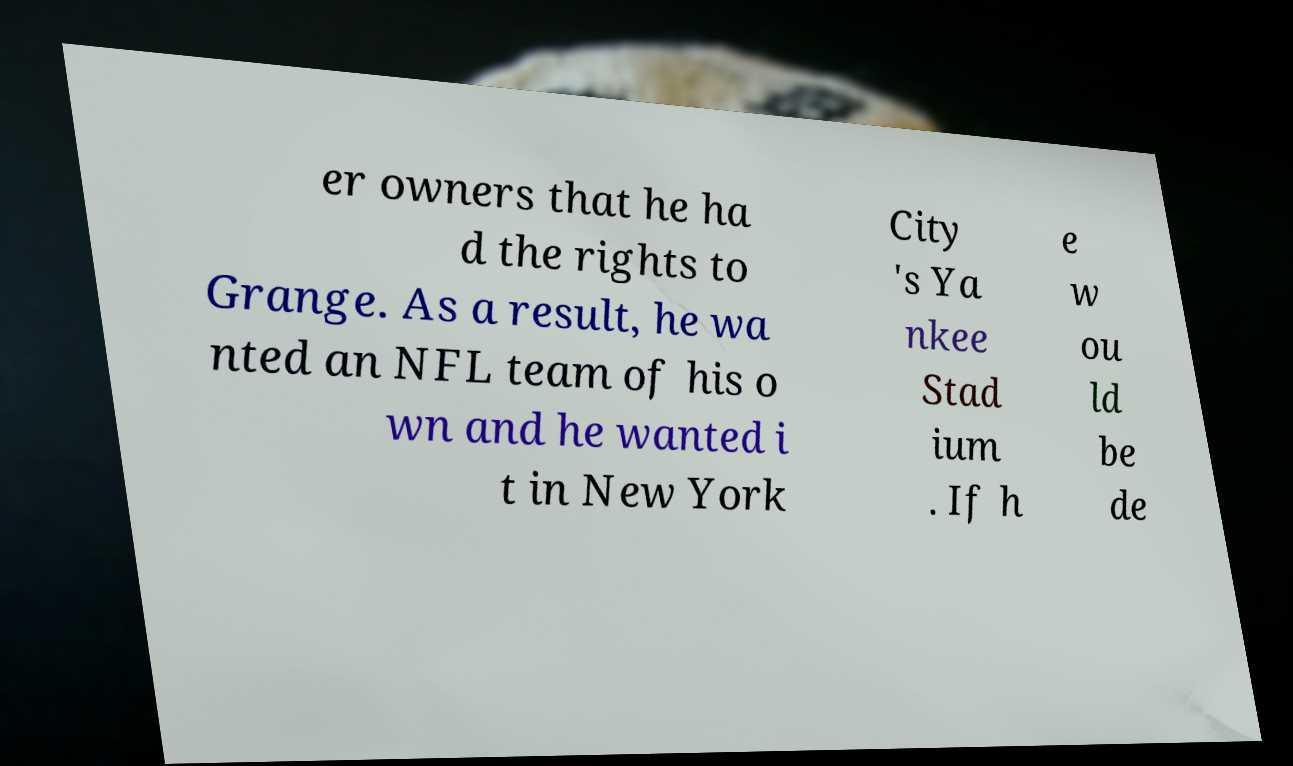Could you extract and type out the text from this image? er owners that he ha d the rights to Grange. As a result, he wa nted an NFL team of his o wn and he wanted i t in New York City 's Ya nkee Stad ium . If h e w ou ld be de 